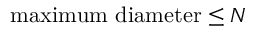<formula> <loc_0><loc_0><loc_500><loc_500>\max i m u m d i a m e t e r \leq N</formula> 